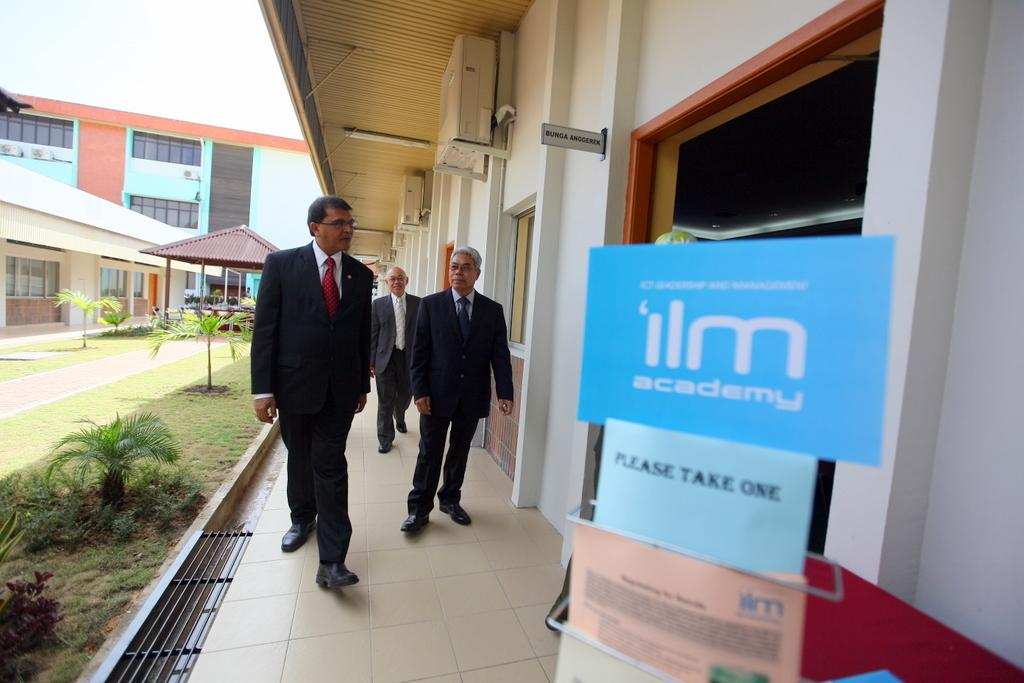<image>
Give a short and clear explanation of the subsequent image. Several men are walking towards a doorway for 'ilm academy. 